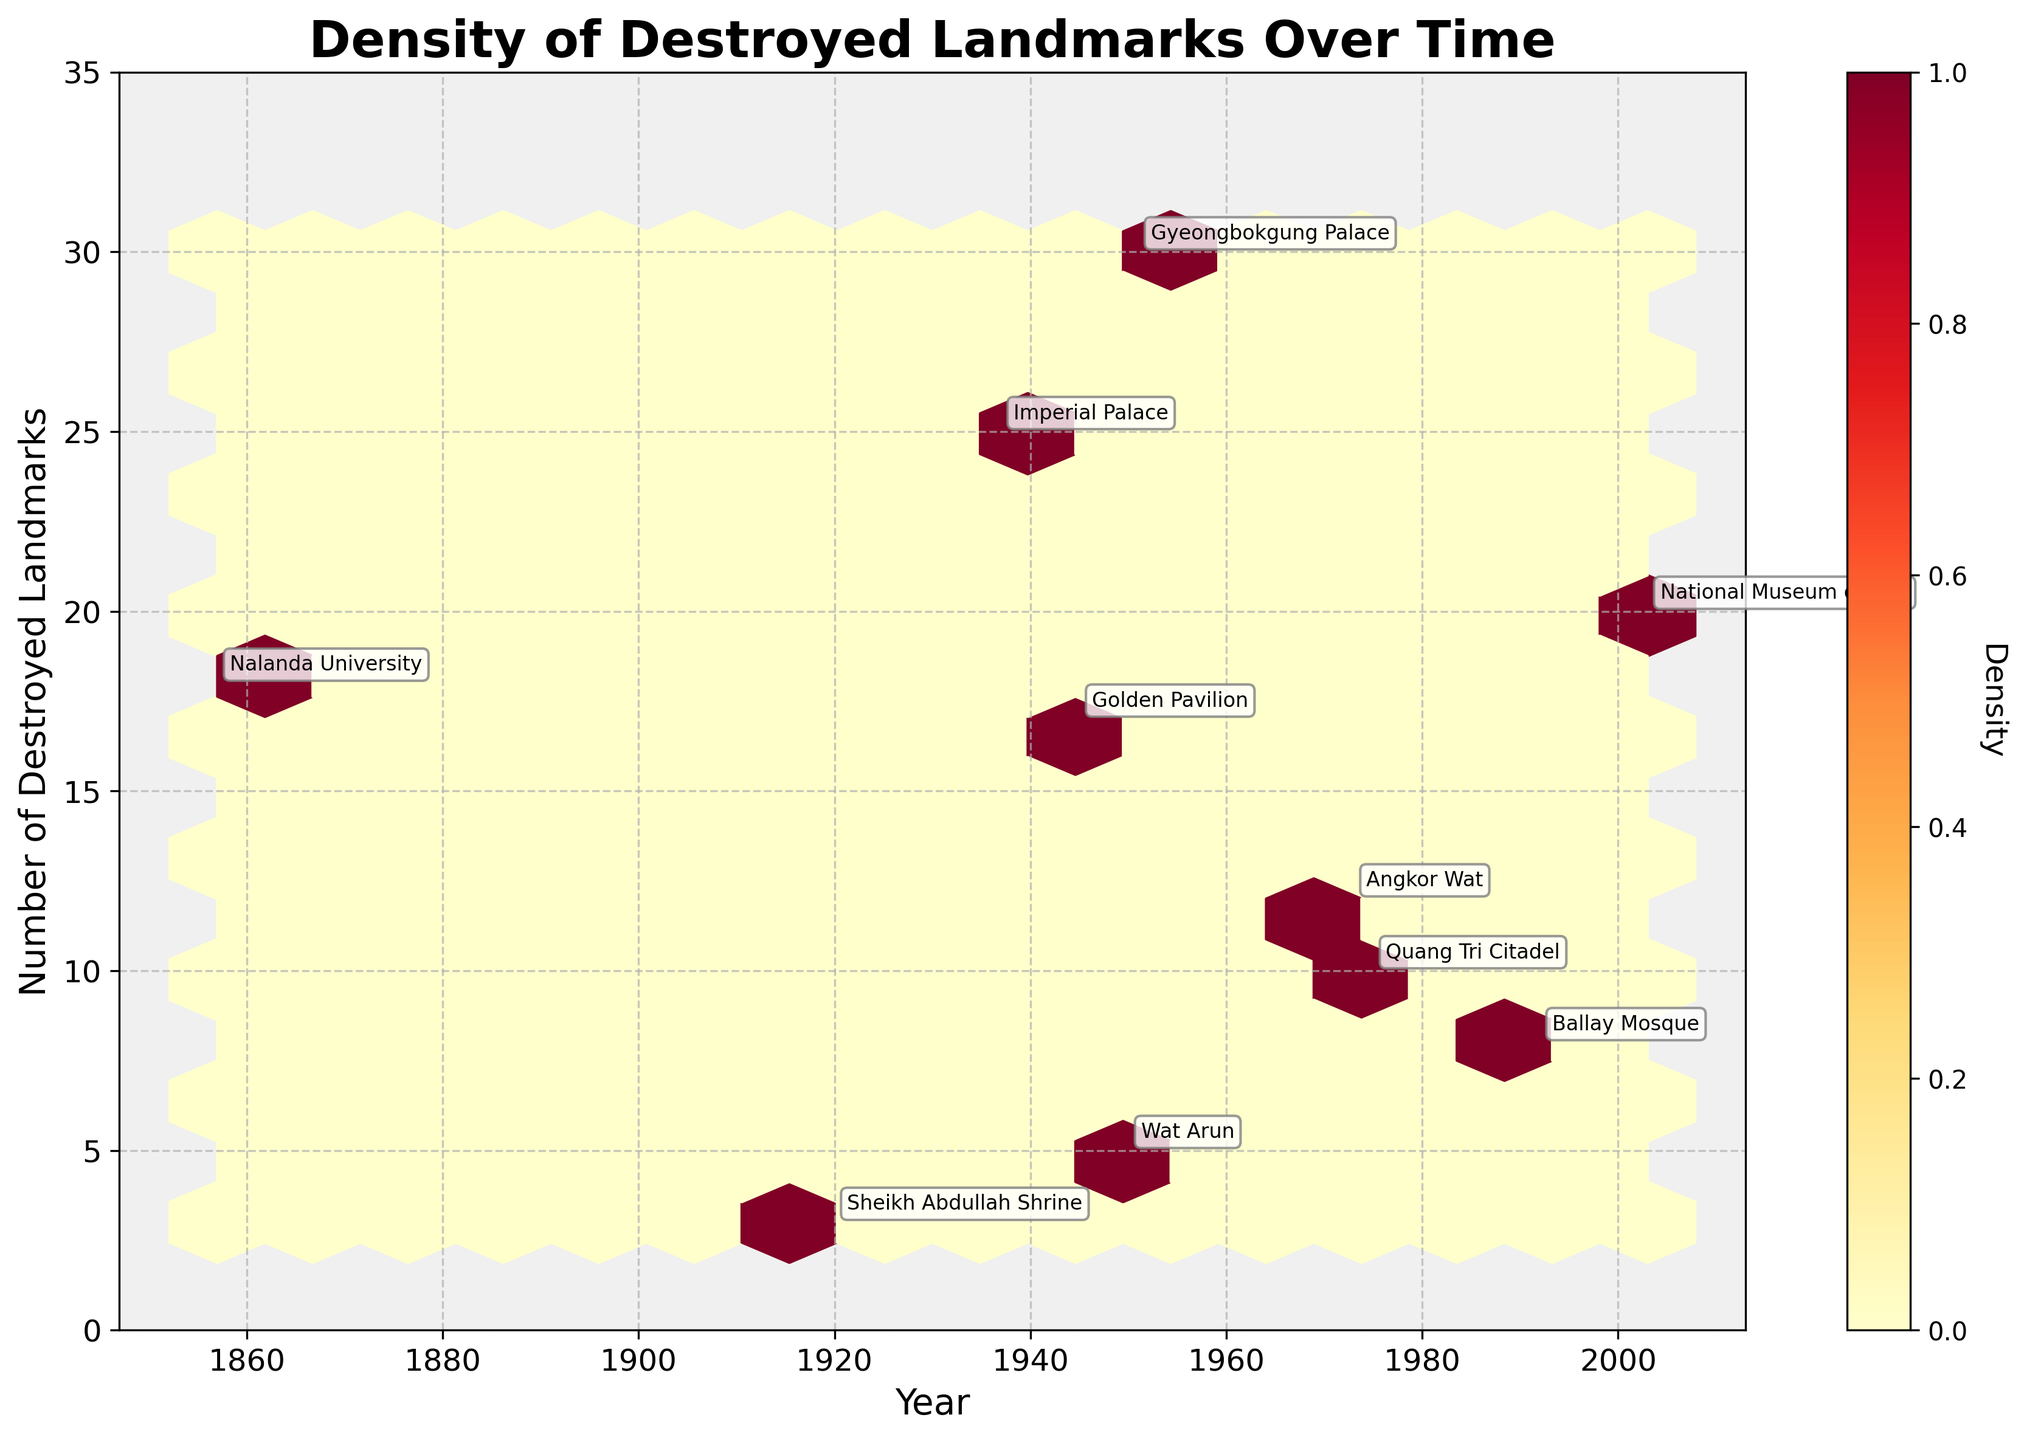How many landmarks were destroyed during the Second Sino-Japanese War? Locate the point for the Second Sino-Japanese War and check the corresponding 'Number of Destroyed Landmarks'. It's 25 in the data.
Answer: 25 Which landmark had the highest number of destroyed landmarks and in which war? Find the highest point on the vertical axis and locate which landmark and war it corresponds to. The highest value is 30 for Gyeongbokgung Palace during the Korean War.
Answer: Gyeongbokgung Palace during the Korean War Is there a period with an especially high density of destroyed landmarks? Examine the color intensity on the density plot. A strong color indicates a higher concentration of destroyed landmarks. The World War II and post-World War II periods show high density around 1945-1950.
Answer: 1945-1950 What is the range of years covered in the plot? Check the horizontal axis from the minimum to maximum year. It ranges from 1857 to 2003.
Answer: 1857 to 2003 How do the numbers of destroyed landmarks compare between World War II and the Vietnam War? Identify the number of destroyed landmarks for both wars. World War II (Golden Pavilion) has 17, the Vietnam War (Quang Tri Citadel) has 10. World War II had more.
Answer: World War II had 7 more What was the number of destroyed landmarks in the earliest and the latest war in the data? Find the minimum and maximum year in the dataset and locate the corresponding 'Destroyed_Landmarks'. Earliest is 1857 with 18 landmarks (Nalanda University), and latest is 2003 with 20 landmarks (National Museum of Iraq).
Answer: 18 in 1857 (Nalanda University) and 20 in 2003 (National Museum of Iraq) Which country experienced the destruction of the most landmarks in a single war according to the figure? Check which point corresponds to the highest number on the y-axis, then identify the country. The highest is 30 during the Korean War for South Korea.
Answer: South Korea How frequent were high-density events (greater than 20 landmarks destroyed) on the plot? Identify the density occurrences where the number of destroyed landmarks exceeds 20. There are three such occurrences: Second Sino-Japanese War (25), Korean War (30), and Iraq War (20).
Answer: Three occurrences Which year saw the greatest destruction of landmarks and how many landmarks were destroyed? Locate the year with the highest vertical point on the figure. The highest number is 30 in 1951 during the Korean War.
Answer: 1951 with 30 landmarks Were there any landmarks destroyed in the 19th century according to the plot? Check if any points appear before 1900 on the horizontal axis. Nalanda University in 1857 represents such an example.
Answer: Yes, in 1857 